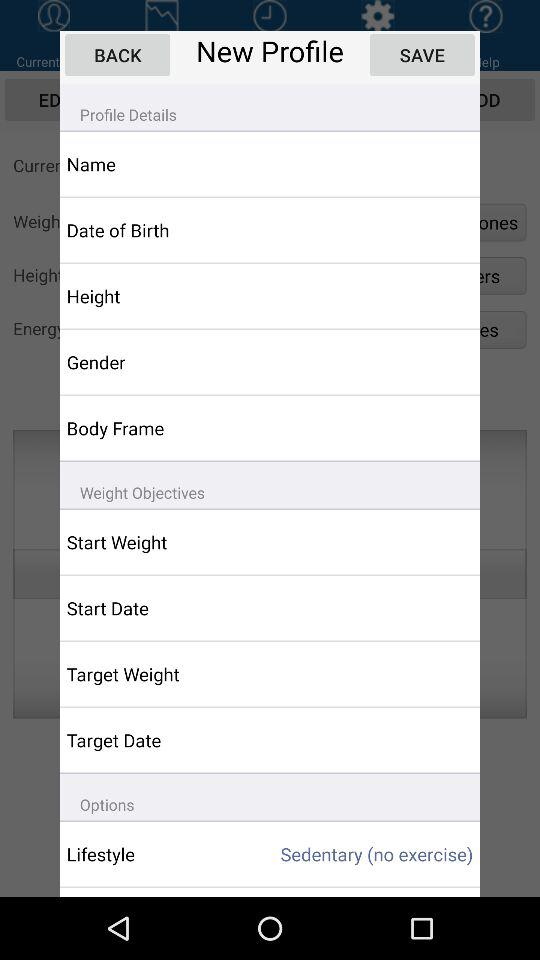What is the lifestyle? The lifestyle is "Sedentary (no exercise)". 